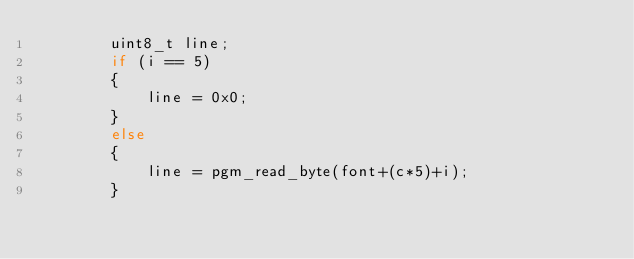<code> <loc_0><loc_0><loc_500><loc_500><_C++_>		uint8_t line;
		if (i == 5)
		{
			line = 0x0;
		}
		else
		{
			line = pgm_read_byte(font+(c*5)+i);
		}
</code> 